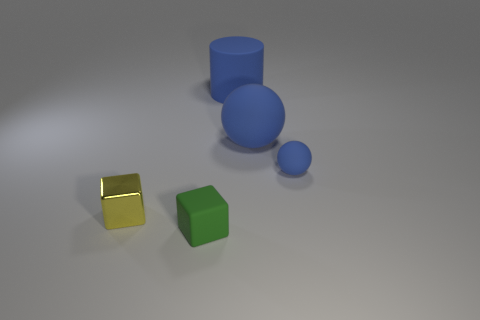Add 3 large red cubes. How many objects exist? 8 Subtract all cubes. How many objects are left? 3 Add 1 large purple cylinders. How many large purple cylinders exist? 1 Subtract 0 green spheres. How many objects are left? 5 Subtract all tiny green matte blocks. Subtract all yellow cubes. How many objects are left? 3 Add 5 blue rubber spheres. How many blue rubber spheres are left? 7 